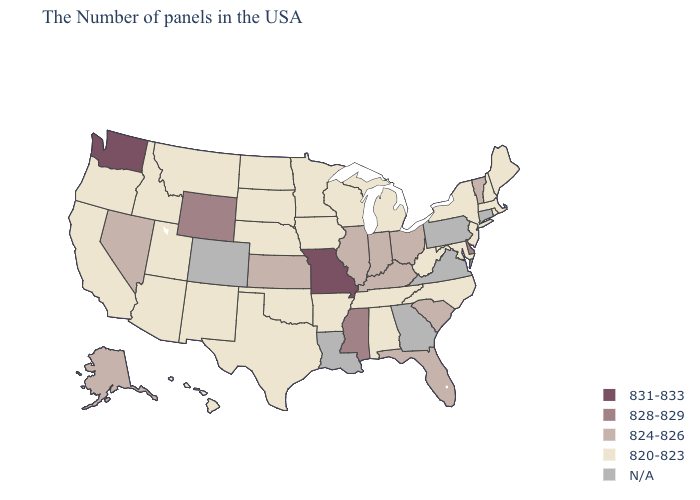Among the states that border California , does Arizona have the highest value?
Answer briefly. No. Which states have the lowest value in the Northeast?
Concise answer only. Maine, Massachusetts, Rhode Island, New Hampshire, New York, New Jersey. Name the states that have a value in the range N/A?
Be succinct. Connecticut, Pennsylvania, Virginia, Georgia, Louisiana, Colorado. What is the lowest value in the MidWest?
Answer briefly. 820-823. How many symbols are there in the legend?
Write a very short answer. 5. Which states have the lowest value in the South?
Quick response, please. Maryland, North Carolina, West Virginia, Alabama, Tennessee, Arkansas, Oklahoma, Texas. What is the value of Tennessee?
Answer briefly. 820-823. Name the states that have a value in the range N/A?
Answer briefly. Connecticut, Pennsylvania, Virginia, Georgia, Louisiana, Colorado. What is the lowest value in the West?
Quick response, please. 820-823. How many symbols are there in the legend?
Keep it brief. 5. Does Vermont have the lowest value in the Northeast?
Quick response, please. No. What is the value of South Carolina?
Keep it brief. 824-826. What is the lowest value in the South?
Be succinct. 820-823. Which states have the highest value in the USA?
Concise answer only. Missouri, Washington. 